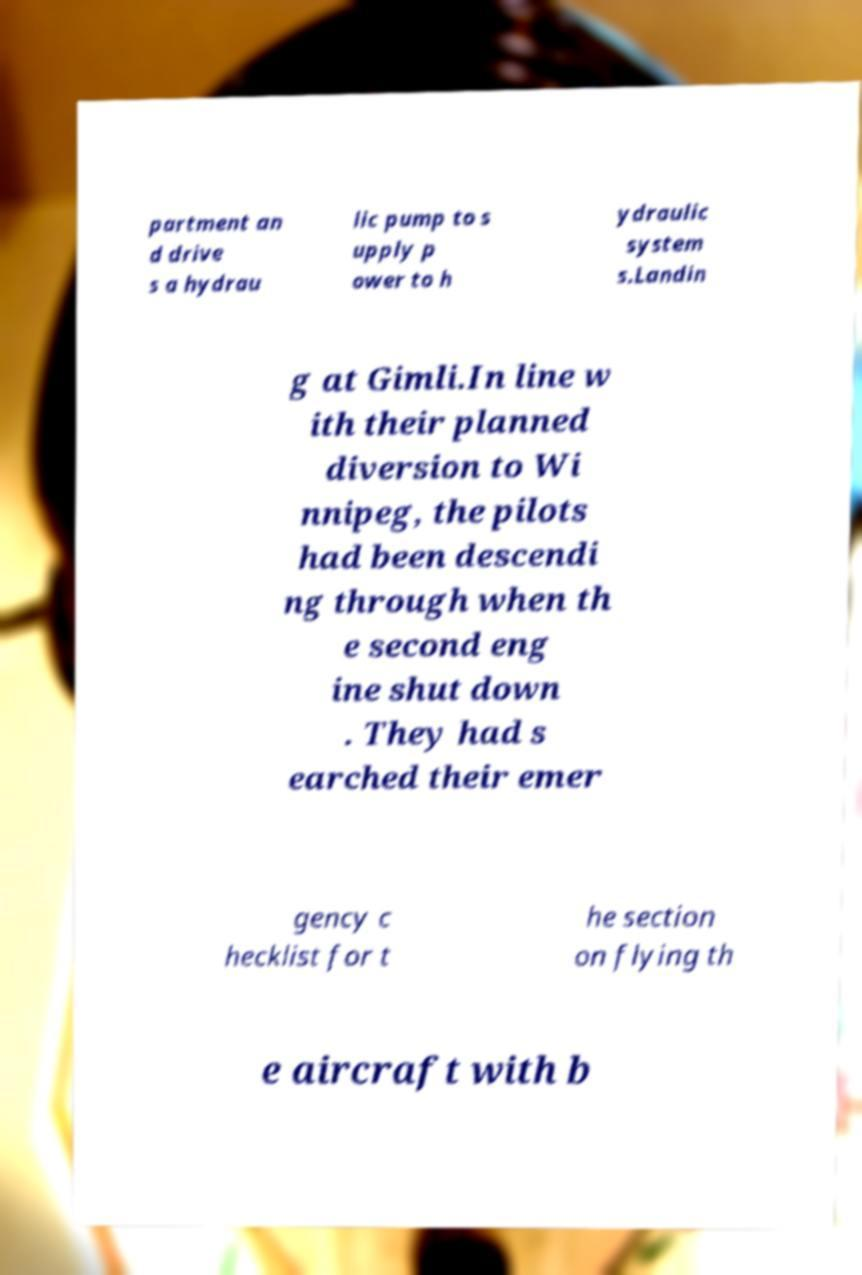Could you extract and type out the text from this image? partment an d drive s a hydrau lic pump to s upply p ower to h ydraulic system s.Landin g at Gimli.In line w ith their planned diversion to Wi nnipeg, the pilots had been descendi ng through when th e second eng ine shut down . They had s earched their emer gency c hecklist for t he section on flying th e aircraft with b 